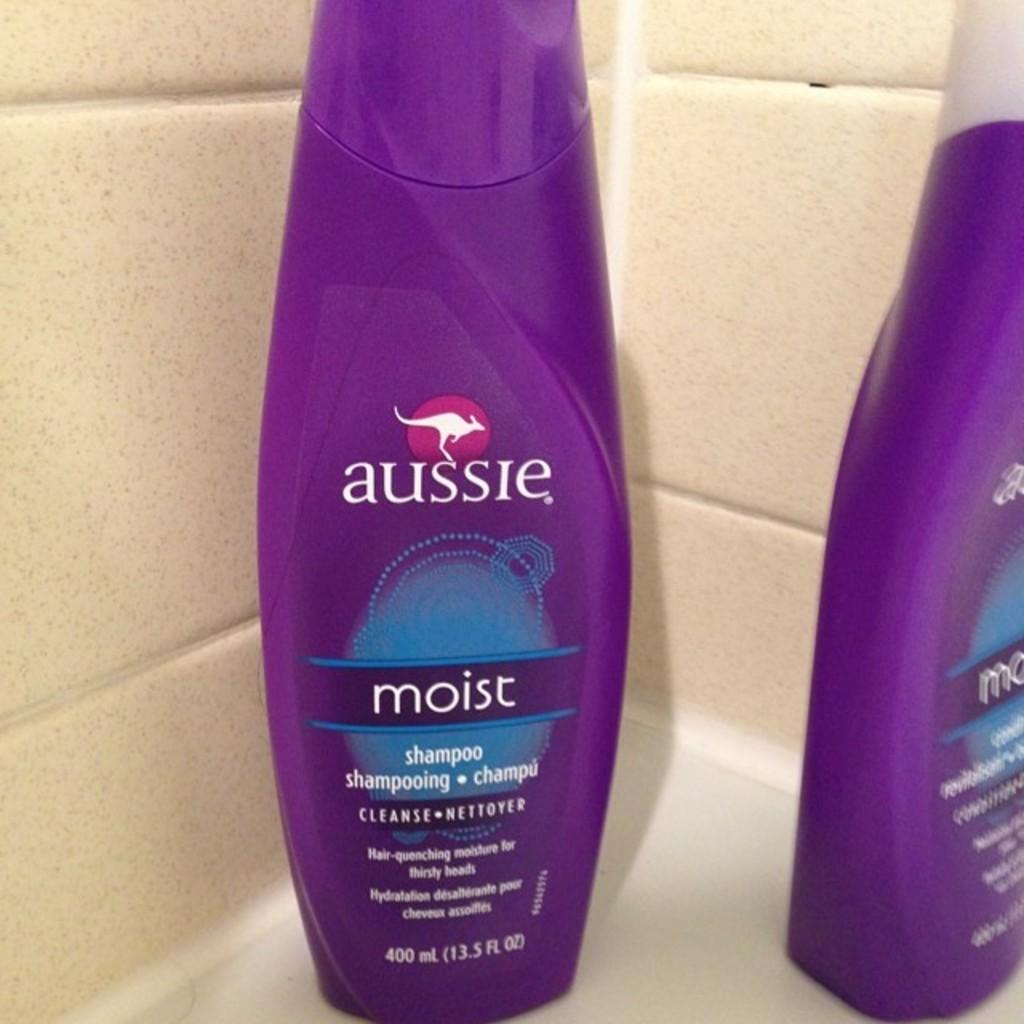What kind of product is in the bottle?
Provide a short and direct response. Shampoo. 